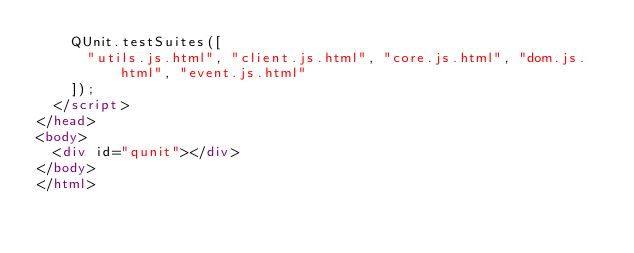Convert code to text. <code><loc_0><loc_0><loc_500><loc_500><_HTML_>    QUnit.testSuites([
      "utils.js.html", "client.js.html", "core.js.html", "dom.js.html", "event.js.html"
    ]);
  </script>
</head>
<body>
  <div id="qunit"></div>
</body>
</html>
</code> 